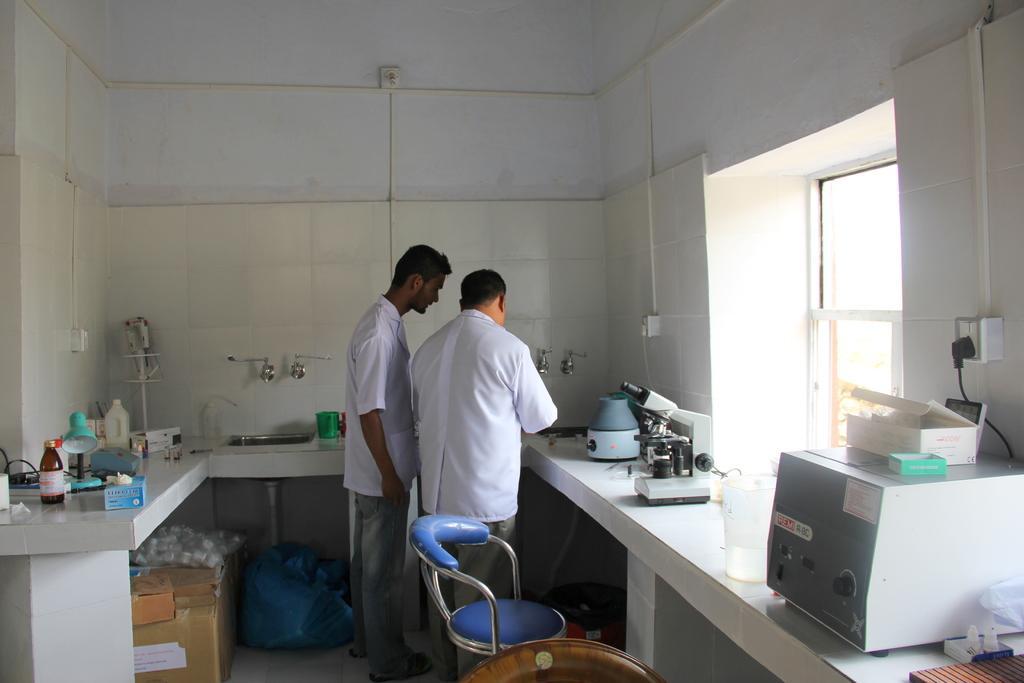Describe this image in one or two sentences. In this image, there is a lab. There are two persons standing and wearing clothes. There is a chair at the bottom of the image. There is a sink, window and some machines on the right side of the image. There is a sink, boxes and some bottles on the left side of the image. 